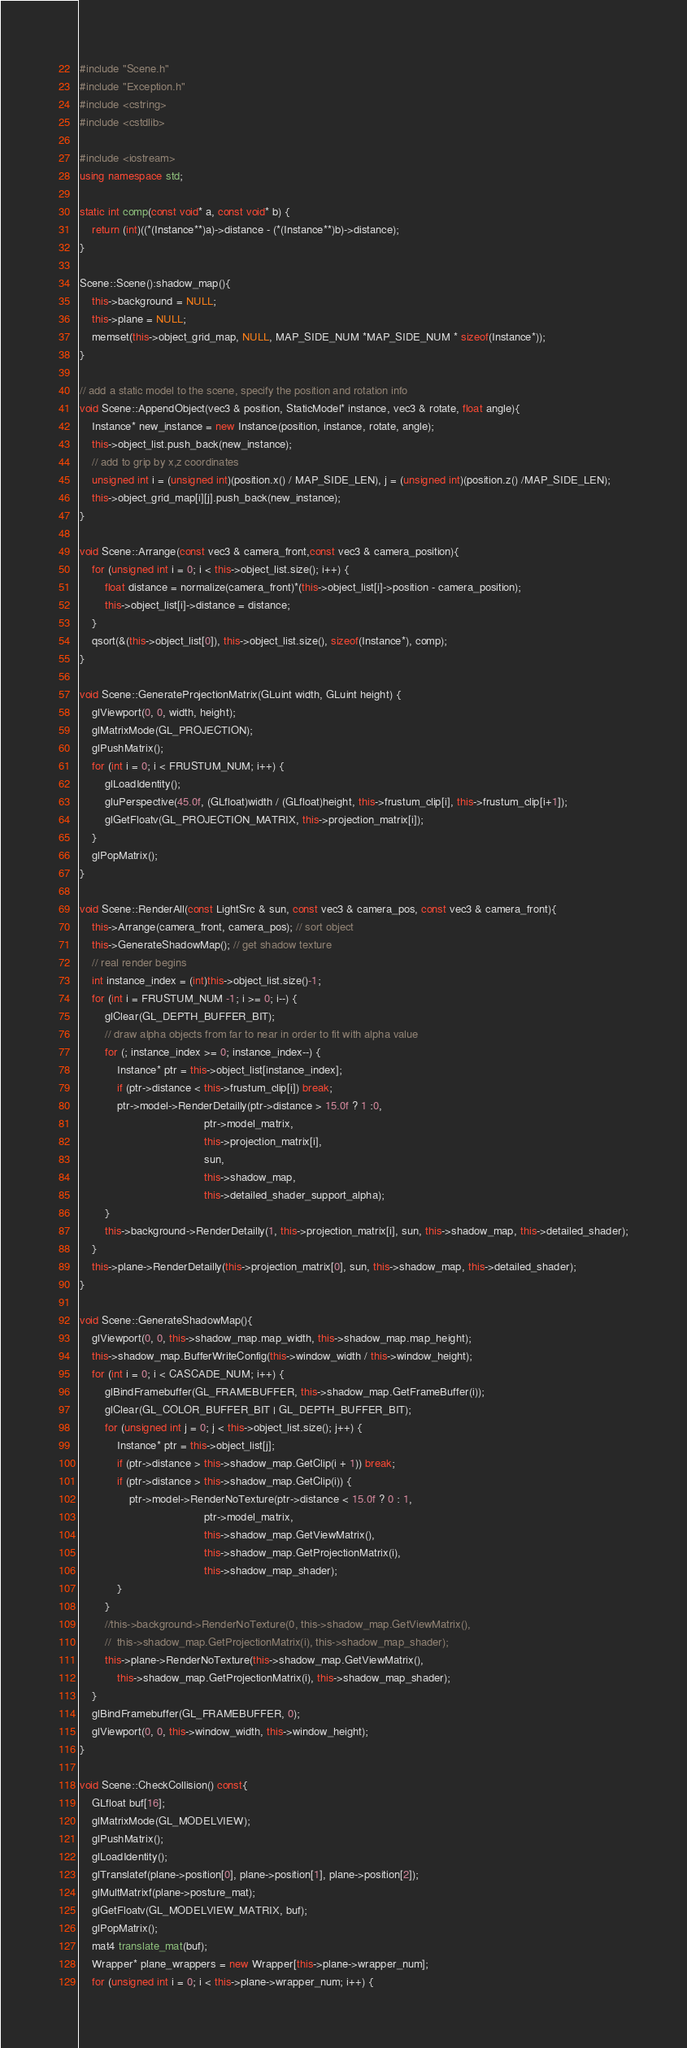Convert code to text. <code><loc_0><loc_0><loc_500><loc_500><_C++_>#include "Scene.h"
#include "Exception.h"
#include <cstring>
#include <cstdlib>

#include <iostream>
using namespace std;

static int comp(const void* a, const void* b) {
	return (int)((*(Instance**)a)->distance - (*(Instance**)b)->distance);
}

Scene::Scene():shadow_map(){
	this->background = NULL;
	this->plane = NULL;
	memset(this->object_grid_map, NULL, MAP_SIDE_NUM *MAP_SIDE_NUM * sizeof(Instance*));
}

// add a static model to the scene, specify the position and rotation info
void Scene::AppendObject(vec3 & position, StaticModel* instance, vec3 & rotate, float angle){
	Instance* new_instance = new Instance(position, instance, rotate, angle);
	this->object_list.push_back(new_instance);
	// add to grip by x,z coordinates
	unsigned int i = (unsigned int)(position.x() / MAP_SIDE_LEN), j = (unsigned int)(position.z() /MAP_SIDE_LEN);
	this->object_grid_map[i][j].push_back(new_instance);
}

void Scene::Arrange(const vec3 & camera_front,const vec3 & camera_position){
	for (unsigned int i = 0; i < this->object_list.size(); i++) {
		float distance = normalize(camera_front)*(this->object_list[i]->position - camera_position);
		this->object_list[i]->distance = distance;
	}
	qsort(&(this->object_list[0]), this->object_list.size(), sizeof(Instance*), comp);
}

void Scene::GenerateProjectionMatrix(GLuint width, GLuint height) {
	glViewport(0, 0, width, height);
	glMatrixMode(GL_PROJECTION);
	glPushMatrix();
	for (int i = 0; i < FRUSTUM_NUM; i++) {
		glLoadIdentity();
		gluPerspective(45.0f, (GLfloat)width / (GLfloat)height, this->frustum_clip[i], this->frustum_clip[i+1]);
		glGetFloatv(GL_PROJECTION_MATRIX, this->projection_matrix[i]);
	}
	glPopMatrix();
}

void Scene::RenderAll(const LightSrc & sun, const vec3 & camera_pos, const vec3 & camera_front){
	this->Arrange(camera_front, camera_pos); // sort object
	this->GenerateShadowMap(); // get shadow texture
	// real render begins
	int instance_index = (int)this->object_list.size()-1;
	for (int i = FRUSTUM_NUM -1; i >= 0; i--) {
		glClear(GL_DEPTH_BUFFER_BIT);
		// draw alpha objects from far to near in order to fit with alpha value
		for (; instance_index >= 0; instance_index--) {
			Instance* ptr = this->object_list[instance_index];
			if (ptr->distance < this->frustum_clip[i]) break;
			ptr->model->RenderDetailly(ptr->distance > 15.0f ? 1 :0, 
										ptr->model_matrix, 
										this->projection_matrix[i], 
										sun, 
										this->shadow_map, 
										this->detailed_shader_support_alpha);
		}
		this->background->RenderDetailly(1, this->projection_matrix[i], sun, this->shadow_map, this->detailed_shader);
	}
	this->plane->RenderDetailly(this->projection_matrix[0], sun, this->shadow_map, this->detailed_shader);
}

void Scene::GenerateShadowMap(){
	glViewport(0, 0, this->shadow_map.map_width, this->shadow_map.map_height);
	this->shadow_map.BufferWriteConfig(this->window_width / this->window_height);
	for (int i = 0; i < CASCADE_NUM; i++) {
		glBindFramebuffer(GL_FRAMEBUFFER, this->shadow_map.GetFrameBuffer(i));
		glClear(GL_COLOR_BUFFER_BIT | GL_DEPTH_BUFFER_BIT);
		for (unsigned int j = 0; j < this->object_list.size(); j++) {
			Instance* ptr = this->object_list[j];
			if (ptr->distance > this->shadow_map.GetClip(i + 1)) break;
			if (ptr->distance > this->shadow_map.GetClip(i)) {
				ptr->model->RenderNoTexture(ptr->distance < 15.0f ? 0 : 1, 
										ptr->model_matrix,
										this->shadow_map.GetViewMatrix(),
										this->shadow_map.GetProjectionMatrix(i), 
										this->shadow_map_shader);
			}
		}
		//this->background->RenderNoTexture(0, this->shadow_map.GetViewMatrix(),
		//	this->shadow_map.GetProjectionMatrix(i), this->shadow_map_shader);
		this->plane->RenderNoTexture(this->shadow_map.GetViewMatrix(),
			this->shadow_map.GetProjectionMatrix(i), this->shadow_map_shader);
	}
	glBindFramebuffer(GL_FRAMEBUFFER, 0);
	glViewport(0, 0, this->window_width, this->window_height);
}

void Scene::CheckCollision() const{
	GLfloat buf[16];
	glMatrixMode(GL_MODELVIEW);
	glPushMatrix();
	glLoadIdentity();
	glTranslatef(plane->position[0], plane->position[1], plane->position[2]);
	glMultMatrixf(plane->posture_mat);
	glGetFloatv(GL_MODELVIEW_MATRIX, buf);
	glPopMatrix();
	mat4 translate_mat(buf);
	Wrapper* plane_wrappers = new Wrapper[this->plane->wrapper_num];
	for (unsigned int i = 0; i < this->plane->wrapper_num; i++) {</code> 